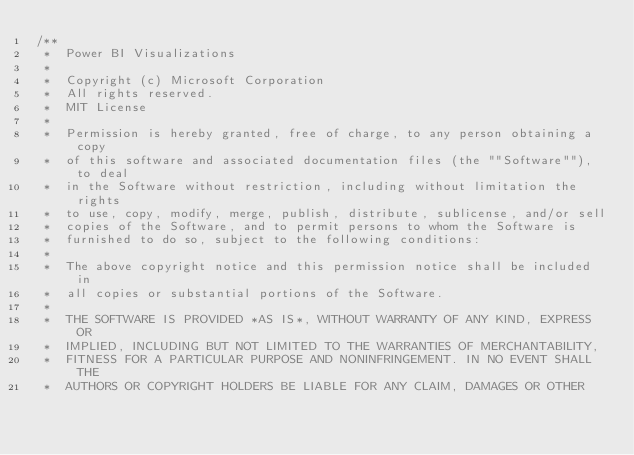Convert code to text. <code><loc_0><loc_0><loc_500><loc_500><_TypeScript_>/**
 *  Power BI Visualizations
 *
 *  Copyright (c) Microsoft Corporation
 *  All rights reserved.
 *  MIT License
 *
 *  Permission is hereby granted, free of charge, to any person obtaining a copy
 *  of this software and associated documentation files (the ""Software""), to deal
 *  in the Software without restriction, including without limitation the rights
 *  to use, copy, modify, merge, publish, distribute, sublicense, and/or sell
 *  copies of the Software, and to permit persons to whom the Software is
 *  furnished to do so, subject to the following conditions:
 *
 *  The above copyright notice and this permission notice shall be included in
 *  all copies or substantial portions of the Software.
 *
 *  THE SOFTWARE IS PROVIDED *AS IS*, WITHOUT WARRANTY OF ANY KIND, EXPRESS OR
 *  IMPLIED, INCLUDING BUT NOT LIMITED TO THE WARRANTIES OF MERCHANTABILITY,
 *  FITNESS FOR A PARTICULAR PURPOSE AND NONINFRINGEMENT. IN NO EVENT SHALL THE
 *  AUTHORS OR COPYRIGHT HOLDERS BE LIABLE FOR ANY CLAIM, DAMAGES OR OTHER</code> 